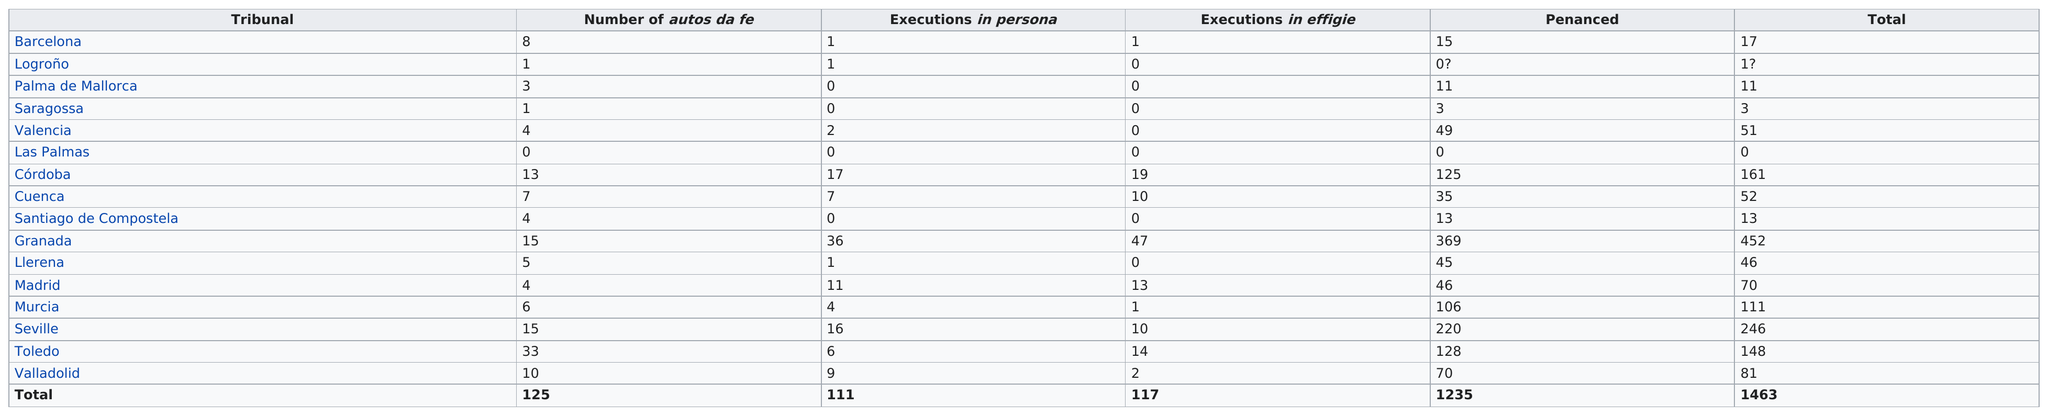Identify some key points in this picture. Seven tribunals executed more than five people in persona. During the time period in question, the Spanish tribunal of Granada conducted a total of 36 executions in person and 47 executions in effigy. Santiago de Compostela and Madrid both held the same number of autos da fe as Valencia. The Granada tribunal had the most executions in effigie. Granada was the only tribunal to have more than 40 executions in effigie. 